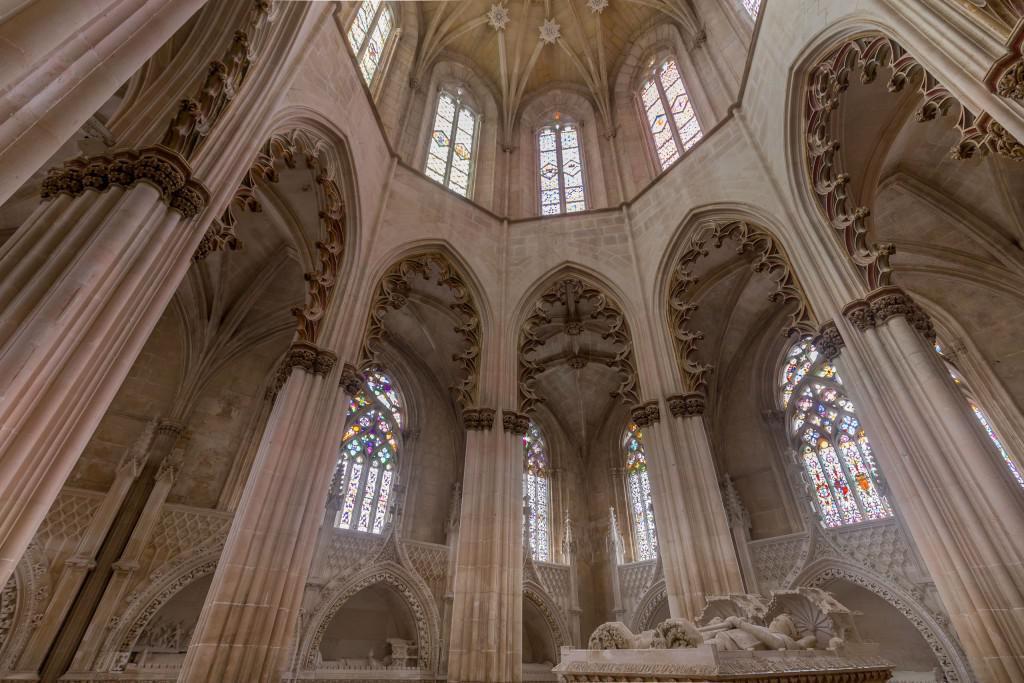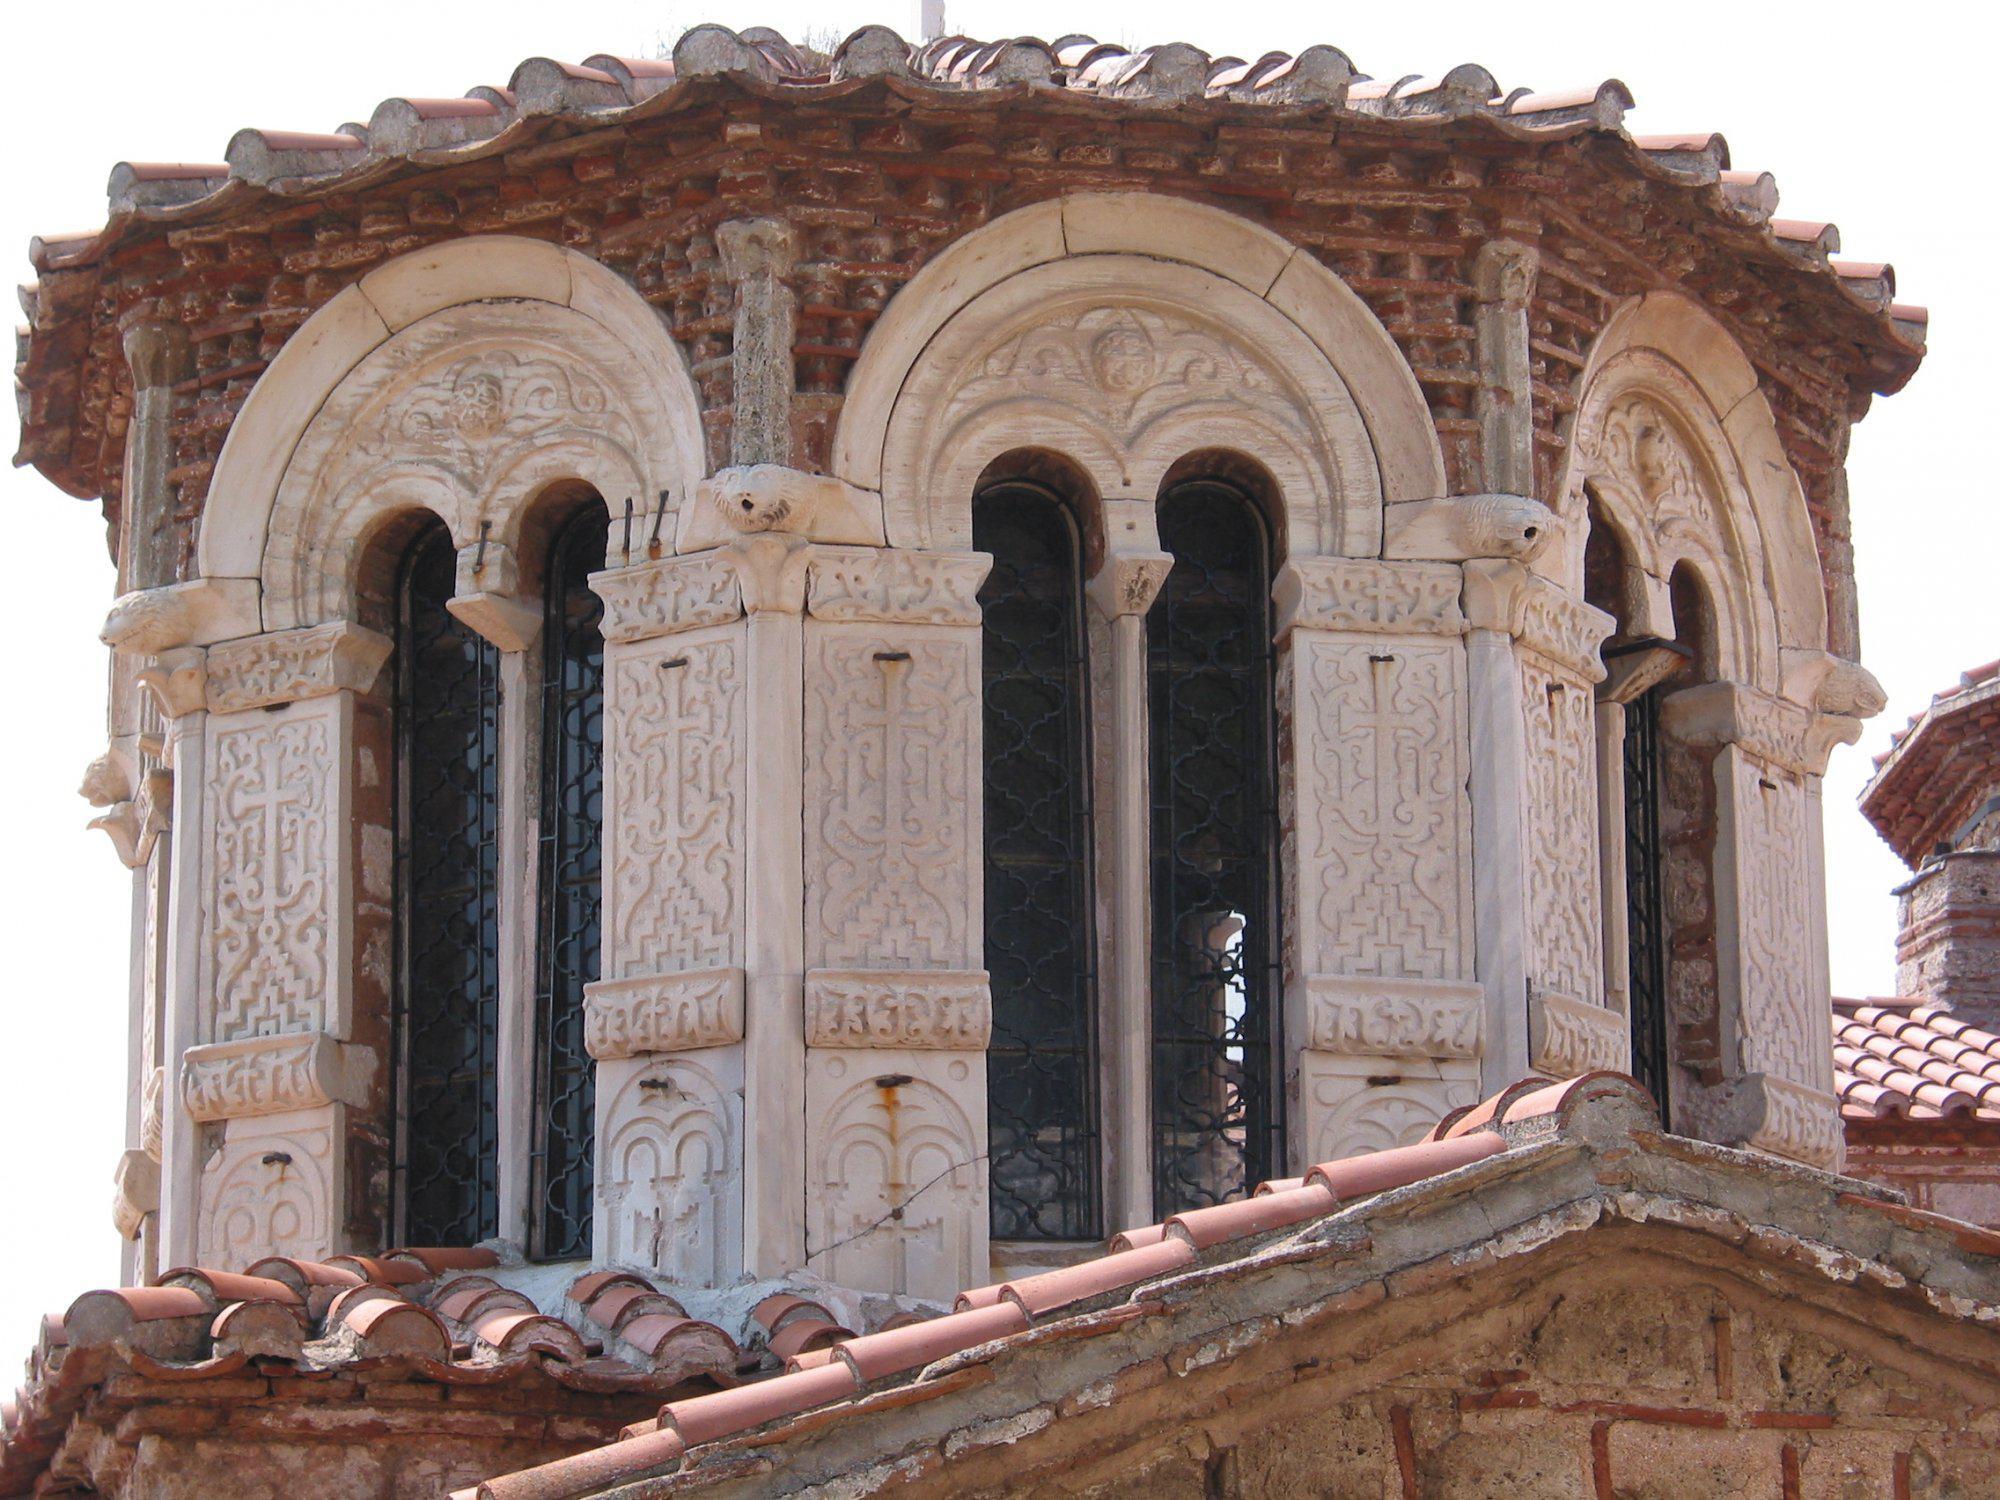The first image is the image on the left, the second image is the image on the right. Examine the images to the left and right. Is the description "In one image, a round fountain structure can be seen near long archway passages that run in two directions." accurate? Answer yes or no. No. The first image is the image on the left, the second image is the image on the right. Evaluate the accuracy of this statement regarding the images: "An image shows a semi-circle of arches, with an opening above them.". Is it true? Answer yes or no. Yes. 